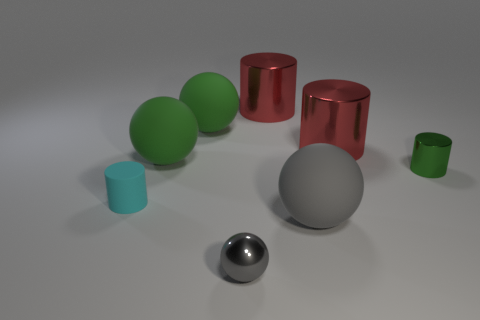Subtract all large spheres. How many spheres are left? 1 Add 1 gray things. How many objects exist? 9 Subtract all gray spheres. How many spheres are left? 2 Subtract all purple spheres. How many brown cylinders are left? 0 Subtract 2 spheres. How many spheres are left? 2 Subtract all blue cylinders. Subtract all cyan balls. How many cylinders are left? 4 Subtract all big purple metal cubes. Subtract all red metallic things. How many objects are left? 6 Add 8 red things. How many red things are left? 10 Add 4 red shiny cylinders. How many red shiny cylinders exist? 6 Subtract 0 brown balls. How many objects are left? 8 